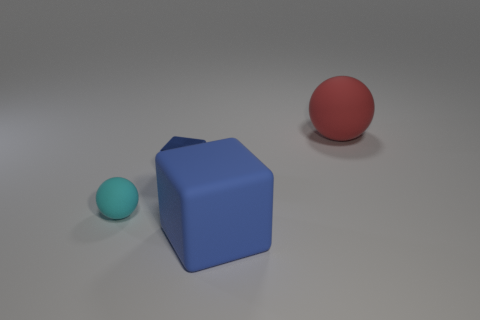What is the size of the rubber sphere that is behind the blue shiny thing?
Your answer should be very brief. Large. What is the size of the cyan thing?
Make the answer very short. Small. What number of cylinders are small objects or big brown metallic things?
Ensure brevity in your answer.  0. What is the size of the red object that is made of the same material as the small cyan thing?
Your answer should be compact. Large. How many tiny rubber spheres have the same color as the big ball?
Keep it short and to the point. 0. There is a cyan sphere; are there any big red things in front of it?
Ensure brevity in your answer.  No. Do the small matte object and the big thing that is behind the tiny cyan matte ball have the same shape?
Offer a very short reply. Yes. How many objects are balls on the left side of the small block or small metallic things?
Provide a short and direct response. 2. Is there anything else that has the same material as the small blue block?
Make the answer very short. No. What number of matte things are behind the tiny matte sphere and in front of the cyan rubber thing?
Offer a terse response. 0. 